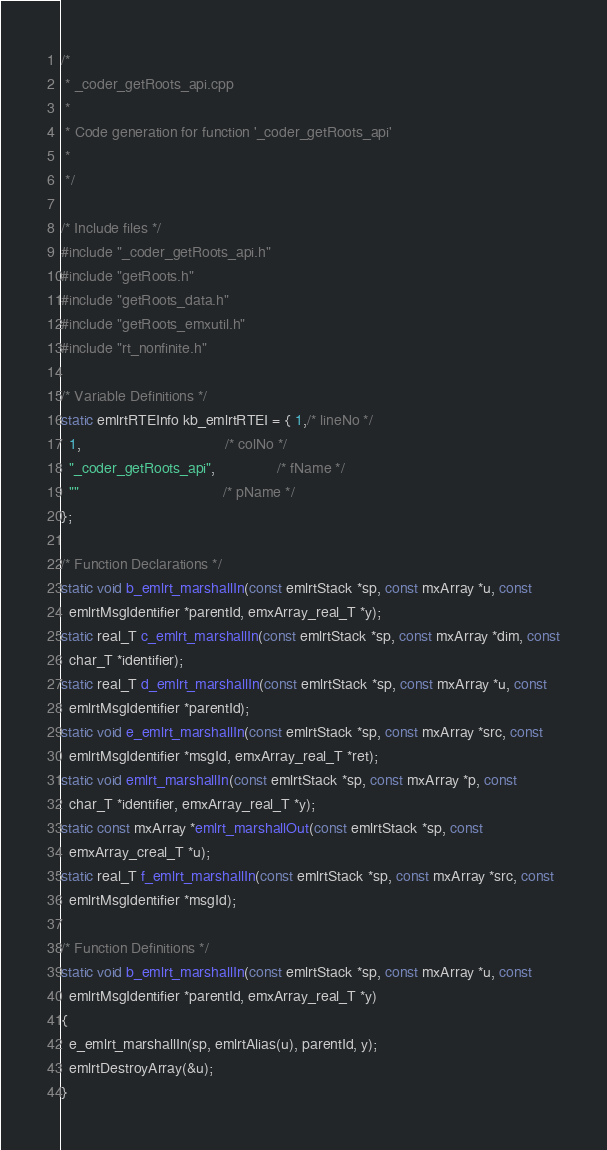Convert code to text. <code><loc_0><loc_0><loc_500><loc_500><_C++_>/*
 * _coder_getRoots_api.cpp
 *
 * Code generation for function '_coder_getRoots_api'
 *
 */

/* Include files */
#include "_coder_getRoots_api.h"
#include "getRoots.h"
#include "getRoots_data.h"
#include "getRoots_emxutil.h"
#include "rt_nonfinite.h"

/* Variable Definitions */
static emlrtRTEInfo kb_emlrtRTEI = { 1,/* lineNo */
  1,                                   /* colNo */
  "_coder_getRoots_api",               /* fName */
  ""                                   /* pName */
};

/* Function Declarations */
static void b_emlrt_marshallIn(const emlrtStack *sp, const mxArray *u, const
  emlrtMsgIdentifier *parentId, emxArray_real_T *y);
static real_T c_emlrt_marshallIn(const emlrtStack *sp, const mxArray *dim, const
  char_T *identifier);
static real_T d_emlrt_marshallIn(const emlrtStack *sp, const mxArray *u, const
  emlrtMsgIdentifier *parentId);
static void e_emlrt_marshallIn(const emlrtStack *sp, const mxArray *src, const
  emlrtMsgIdentifier *msgId, emxArray_real_T *ret);
static void emlrt_marshallIn(const emlrtStack *sp, const mxArray *p, const
  char_T *identifier, emxArray_real_T *y);
static const mxArray *emlrt_marshallOut(const emlrtStack *sp, const
  emxArray_creal_T *u);
static real_T f_emlrt_marshallIn(const emlrtStack *sp, const mxArray *src, const
  emlrtMsgIdentifier *msgId);

/* Function Definitions */
static void b_emlrt_marshallIn(const emlrtStack *sp, const mxArray *u, const
  emlrtMsgIdentifier *parentId, emxArray_real_T *y)
{
  e_emlrt_marshallIn(sp, emlrtAlias(u), parentId, y);
  emlrtDestroyArray(&u);
}
</code> 